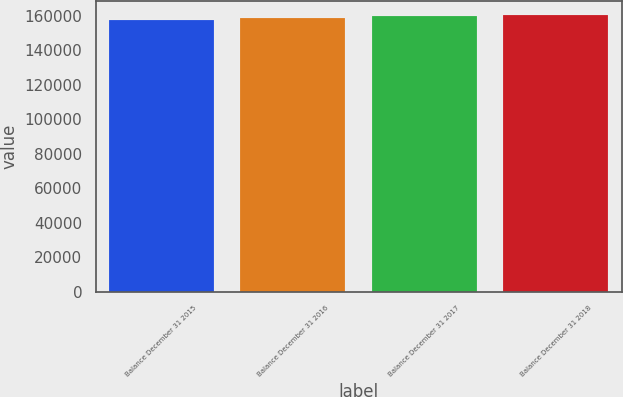Convert chart to OTSL. <chart><loc_0><loc_0><loc_500><loc_500><bar_chart><fcel>Balance December 31 2015<fcel>Balance December 31 2016<fcel>Balance December 31 2017<fcel>Balance December 31 2018<nl><fcel>157677<fcel>158634<fcel>159845<fcel>160472<nl></chart> 